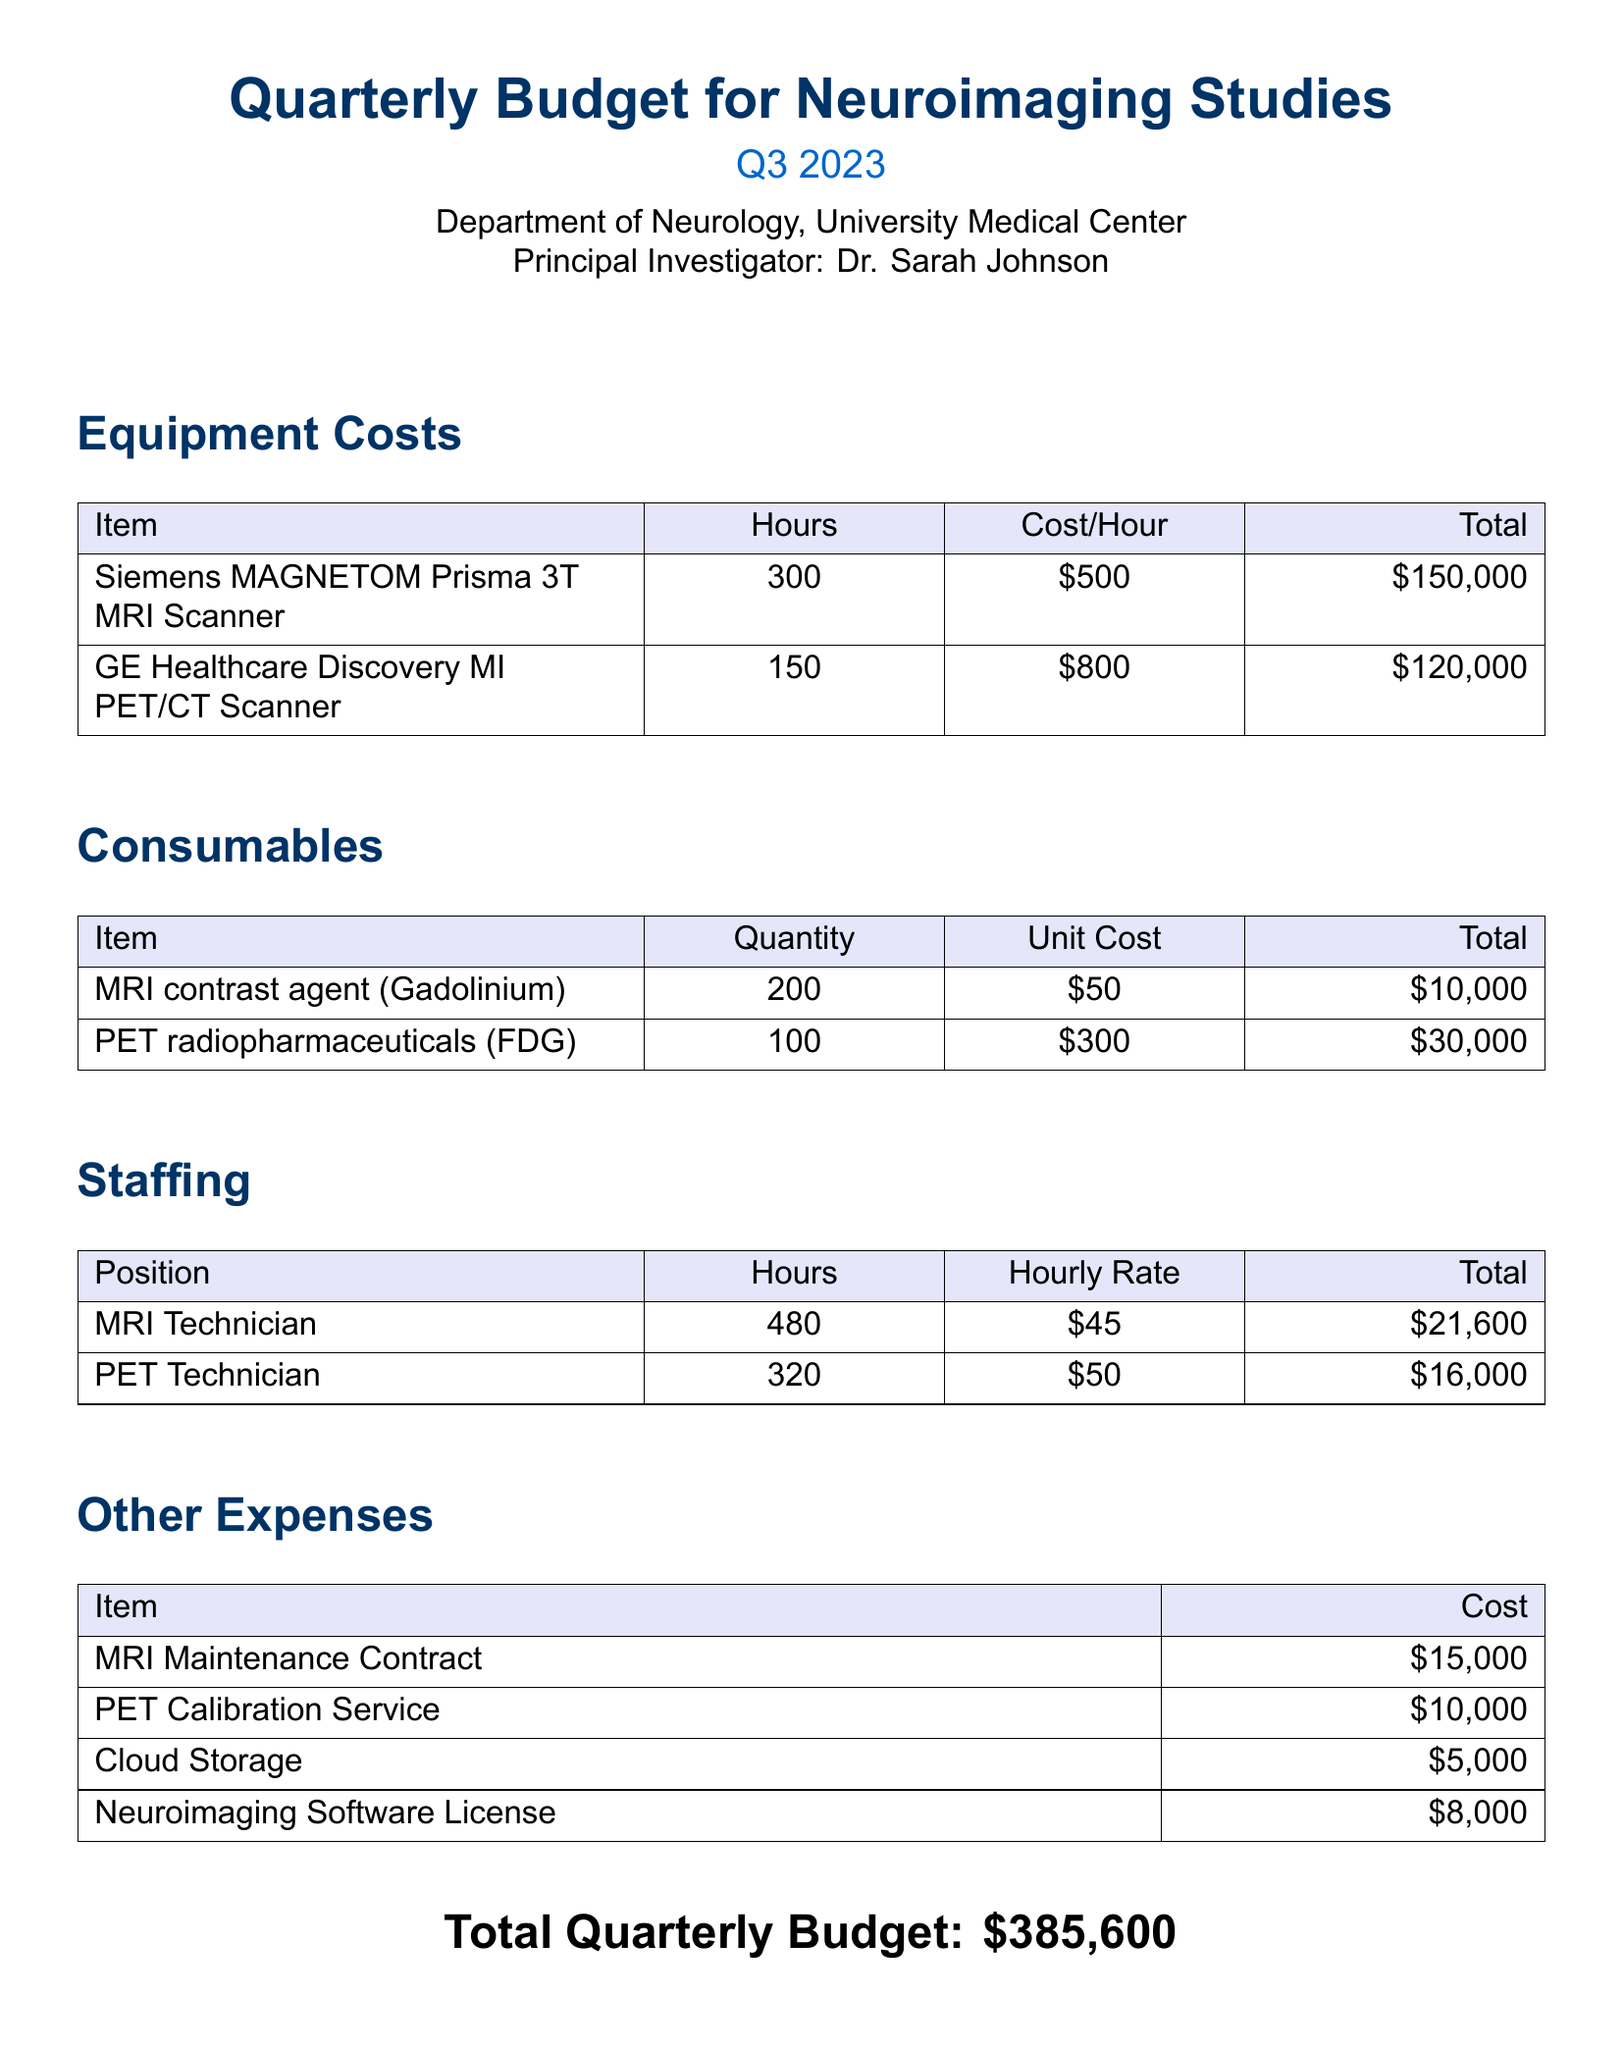What is the total cost for MRI scanner usage? The total cost for MRI scanner usage is calculated as 300 hours multiplied by the cost per hour of $500, which equals $150,000.
Answer: $150,000 What is the hourly rate for PET technicians? The hourly rate for PET technicians is given in the staffing section as $50 per hour.
Answer: $50 How many MRI contrast agents were ordered? The quantity of MRI contrast agents ordered is stated as 200 in the consumables section of the document.
Answer: 200 What is the total cost for PET calibration service? The cost for PET calibration service is presented as $10,000 under other expenses.
Answer: $10,000 What is the total number of hours for MRI technician? The total number of hours for the MRI technician is listed as 480 hours in the staffing table.
Answer: 480 What is the total cost for neuroimaging software license? The cost for the neuroimaging software license is provided as $8,000 in the other expenses section.
Answer: $8,000 What is the total budget for the quarter? The total budget for the quarter is clearly stated at the end of the document as $385,600.
Answer: $385,600 How much was budgeted for PET radiopharmaceuticals? The budgeted amount for PET radiopharmaceuticals is $30,000 as detailed in the consumables section.
Answer: $30,000 What is the total cost for staffing? The total staffing cost can be derived from adding the costs for both MRI and PET technicians, which equals $21,600 + $16,000 = $37,600.
Answer: $37,600 